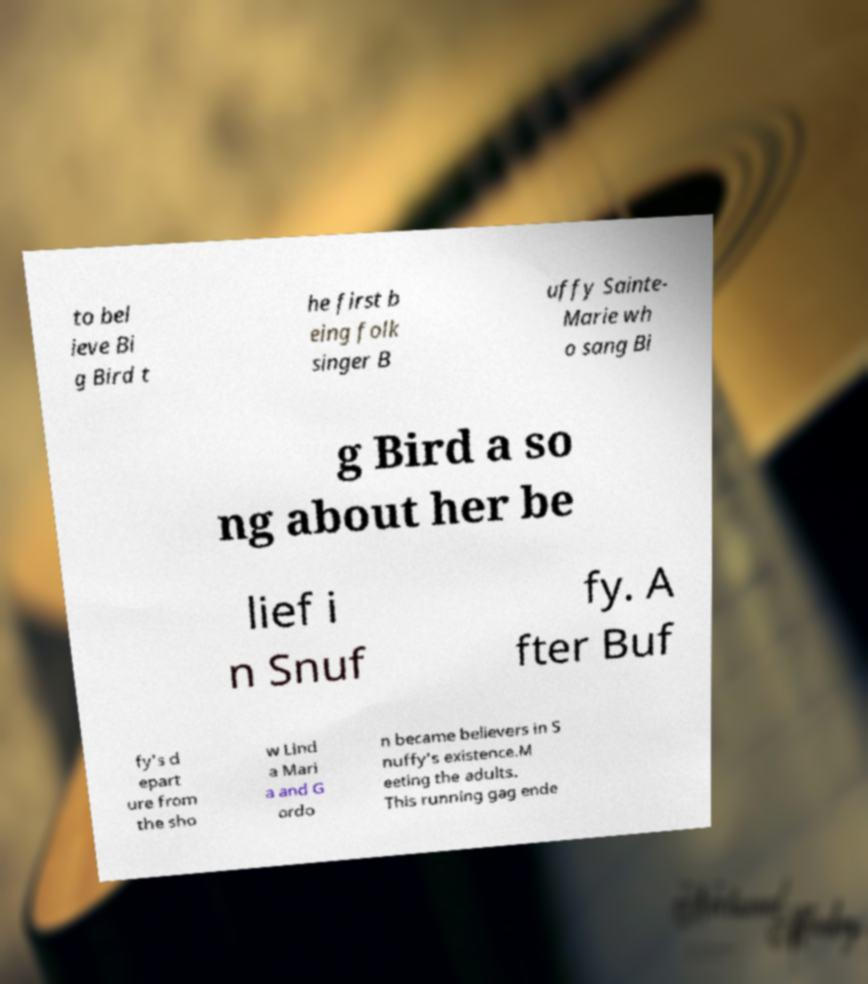Please read and relay the text visible in this image. What does it say? to bel ieve Bi g Bird t he first b eing folk singer B uffy Sainte- Marie wh o sang Bi g Bird a so ng about her be lief i n Snuf fy. A fter Buf fy's d epart ure from the sho w Lind a Mari a and G ordo n became believers in S nuffy's existence.M eeting the adults. This running gag ende 